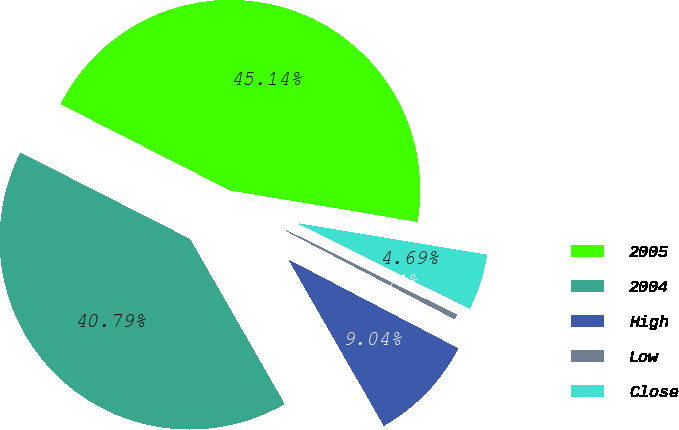Convert chart to OTSL. <chart><loc_0><loc_0><loc_500><loc_500><pie_chart><fcel>2005<fcel>2004<fcel>High<fcel>Low<fcel>Close<nl><fcel>45.14%<fcel>40.79%<fcel>9.04%<fcel>0.34%<fcel>4.69%<nl></chart> 